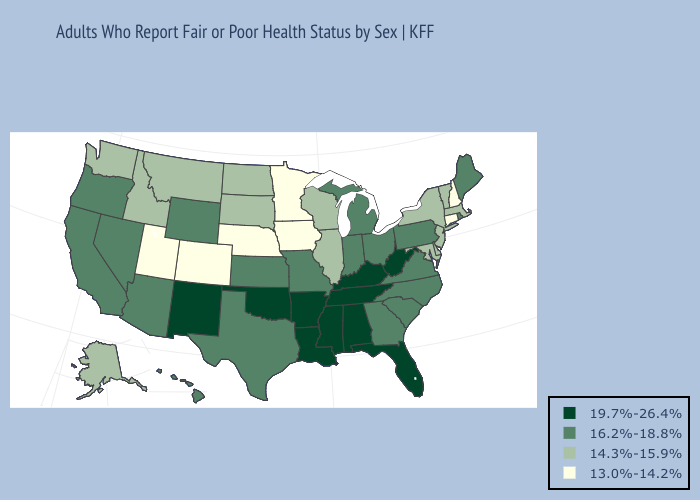What is the value of Rhode Island?
Be succinct. 16.2%-18.8%. Does North Dakota have a lower value than Wisconsin?
Write a very short answer. No. Name the states that have a value in the range 16.2%-18.8%?
Answer briefly. Arizona, California, Georgia, Hawaii, Indiana, Kansas, Maine, Michigan, Missouri, Nevada, North Carolina, Ohio, Oregon, Pennsylvania, Rhode Island, South Carolina, Texas, Virginia, Wyoming. Does Texas have a lower value than Kentucky?
Write a very short answer. Yes. Does Ohio have the highest value in the MidWest?
Quick response, please. Yes. Does South Carolina have the same value as Hawaii?
Answer briefly. Yes. What is the value of North Dakota?
Quick response, please. 14.3%-15.9%. Does the first symbol in the legend represent the smallest category?
Quick response, please. No. What is the lowest value in the MidWest?
Keep it brief. 13.0%-14.2%. Name the states that have a value in the range 13.0%-14.2%?
Keep it brief. Colorado, Connecticut, Iowa, Minnesota, Nebraska, New Hampshire, Utah. Does Vermont have the same value as South Dakota?
Write a very short answer. Yes. Name the states that have a value in the range 13.0%-14.2%?
Write a very short answer. Colorado, Connecticut, Iowa, Minnesota, Nebraska, New Hampshire, Utah. Name the states that have a value in the range 16.2%-18.8%?
Keep it brief. Arizona, California, Georgia, Hawaii, Indiana, Kansas, Maine, Michigan, Missouri, Nevada, North Carolina, Ohio, Oregon, Pennsylvania, Rhode Island, South Carolina, Texas, Virginia, Wyoming. Name the states that have a value in the range 14.3%-15.9%?
Answer briefly. Alaska, Delaware, Idaho, Illinois, Maryland, Massachusetts, Montana, New Jersey, New York, North Dakota, South Dakota, Vermont, Washington, Wisconsin. Which states hav the highest value in the West?
Be succinct. New Mexico. 